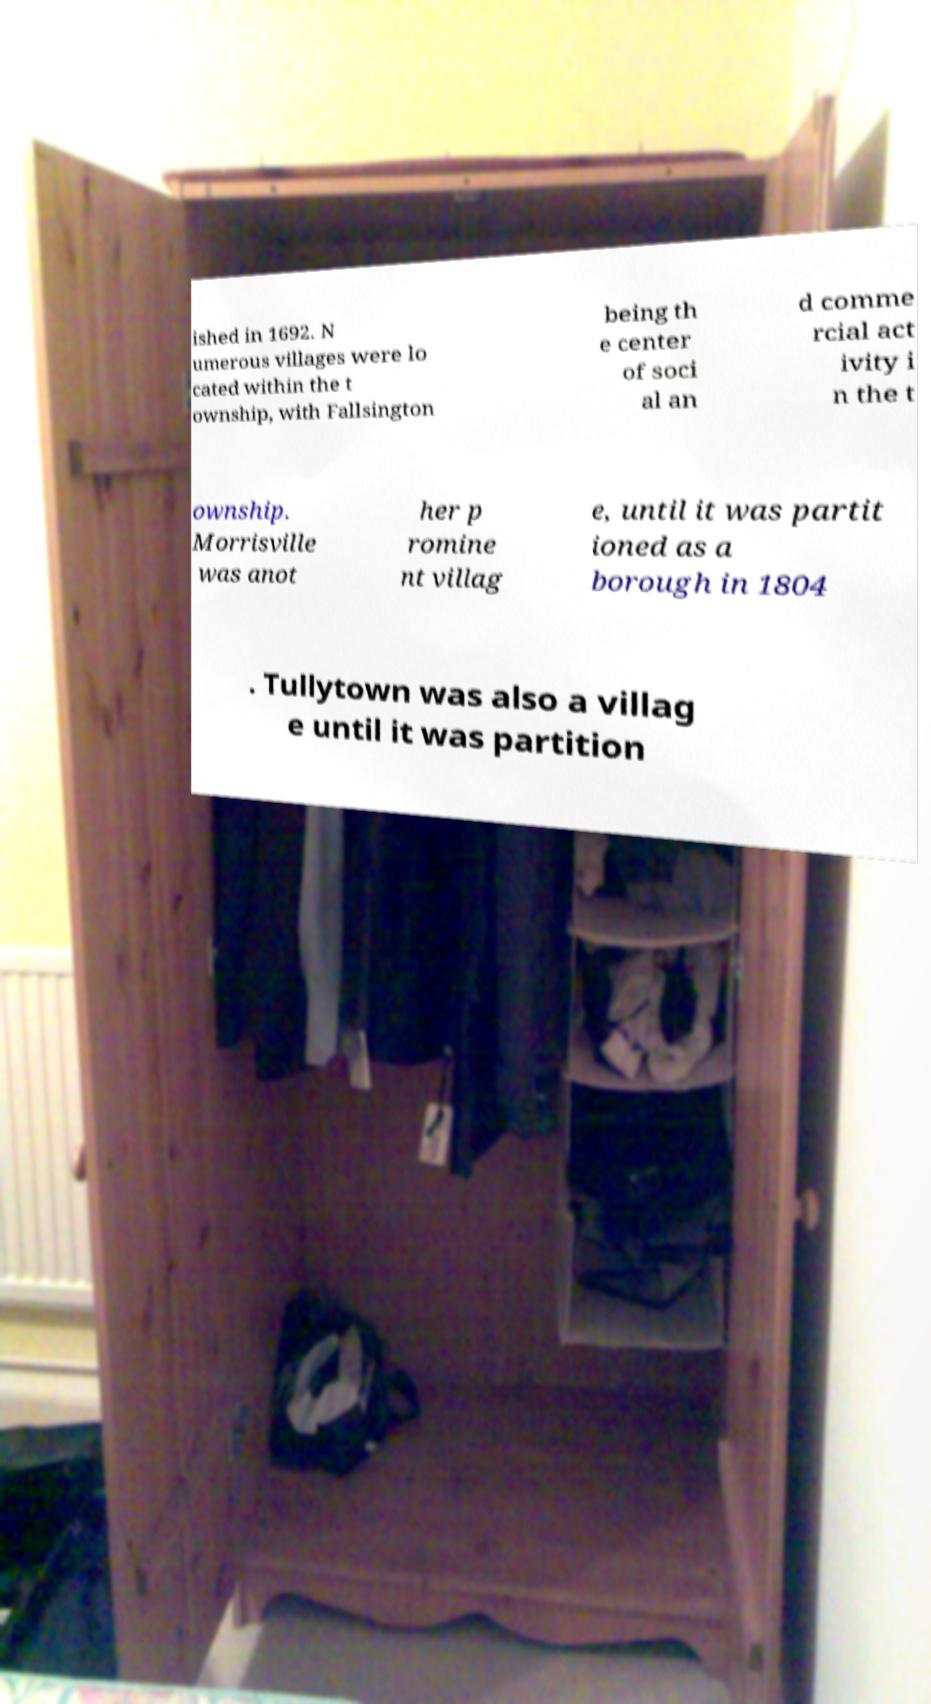I need the written content from this picture converted into text. Can you do that? ished in 1692. N umerous villages were lo cated within the t ownship, with Fallsington being th e center of soci al an d comme rcial act ivity i n the t ownship. Morrisville was anot her p romine nt villag e, until it was partit ioned as a borough in 1804 . Tullytown was also a villag e until it was partition 